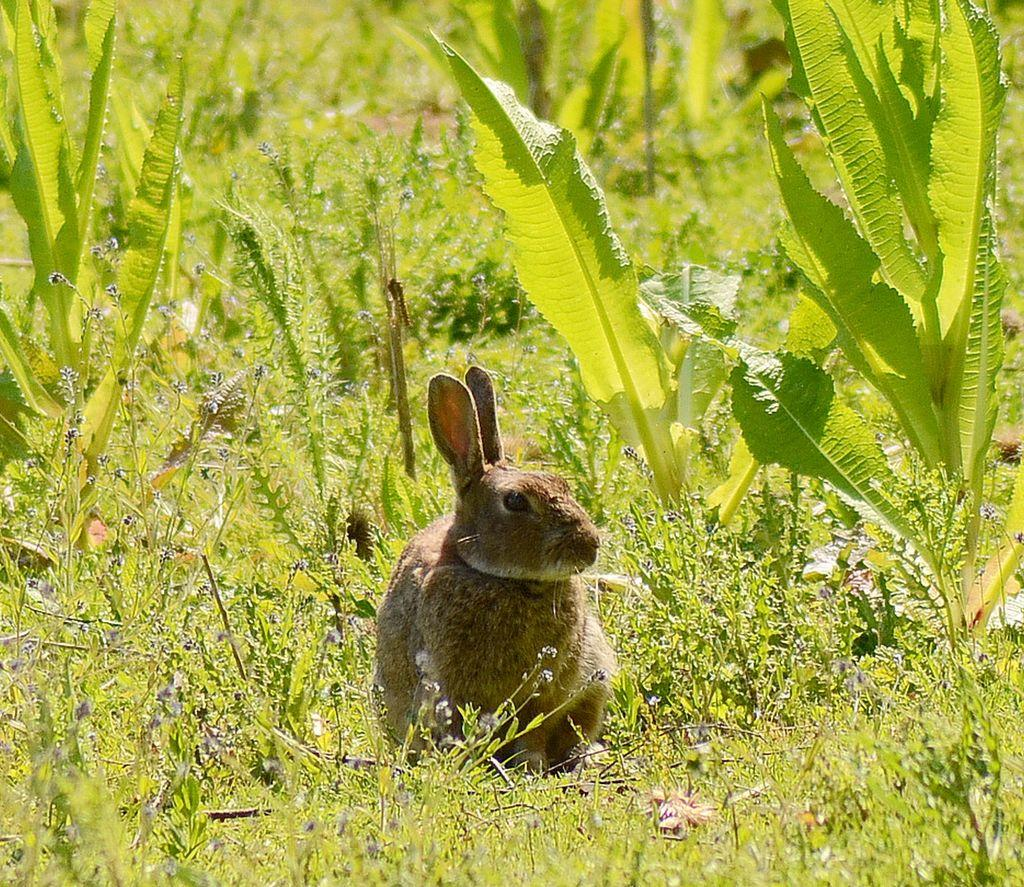What type of animal is in the image? There is a brown color rabbit in the image. What else can be seen in the image besides the rabbit? There are plants in the image. Can you describe the background of the image? The background of the image is blurred. Is the rabbit breathing underwater in the image? The image does not depict the rabbit underwater, and rabbits do not have the ability to breathe underwater. 